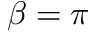<formula> <loc_0><loc_0><loc_500><loc_500>\beta = \pi</formula> 